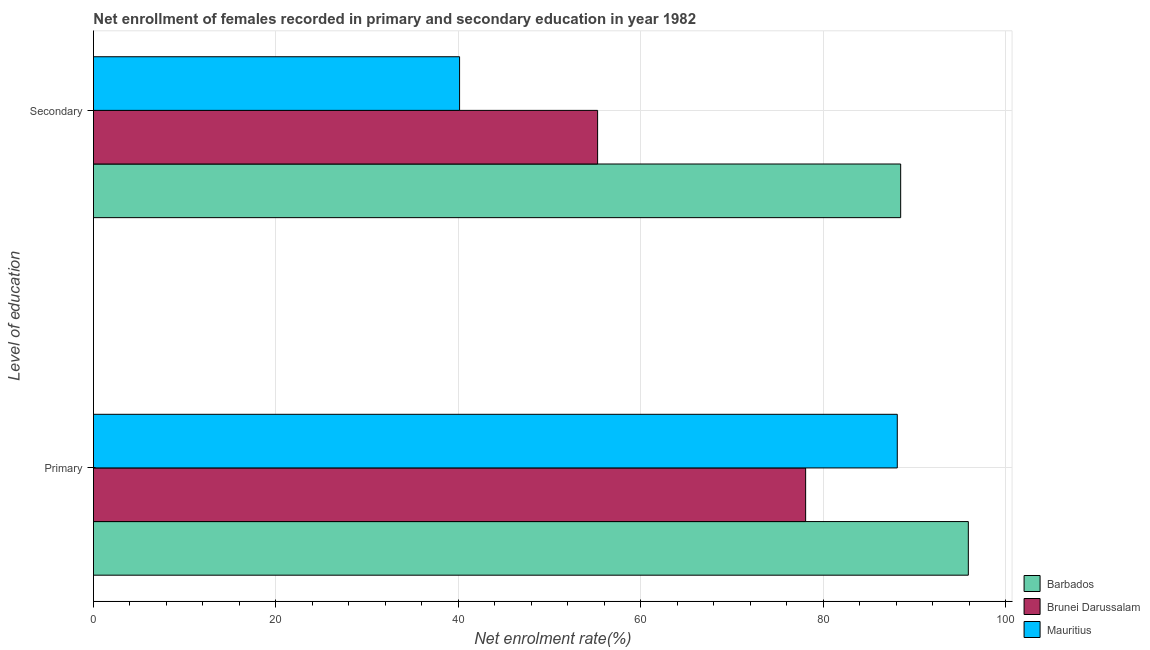How many different coloured bars are there?
Ensure brevity in your answer.  3. How many bars are there on the 1st tick from the top?
Your response must be concise. 3. What is the label of the 1st group of bars from the top?
Offer a terse response. Secondary. What is the enrollment rate in secondary education in Brunei Darussalam?
Your answer should be very brief. 55.26. Across all countries, what is the maximum enrollment rate in secondary education?
Make the answer very short. 88.48. Across all countries, what is the minimum enrollment rate in secondary education?
Provide a short and direct response. 40.13. In which country was the enrollment rate in secondary education maximum?
Your answer should be very brief. Barbados. In which country was the enrollment rate in primary education minimum?
Your answer should be very brief. Brunei Darussalam. What is the total enrollment rate in secondary education in the graph?
Your answer should be very brief. 183.87. What is the difference between the enrollment rate in primary education in Brunei Darussalam and that in Mauritius?
Give a very brief answer. -10.05. What is the difference between the enrollment rate in secondary education in Brunei Darussalam and the enrollment rate in primary education in Mauritius?
Offer a terse response. -32.85. What is the average enrollment rate in primary education per country?
Ensure brevity in your answer.  87.35. What is the difference between the enrollment rate in primary education and enrollment rate in secondary education in Brunei Darussalam?
Your answer should be very brief. 22.8. What is the ratio of the enrollment rate in primary education in Mauritius to that in Brunei Darussalam?
Keep it short and to the point. 1.13. In how many countries, is the enrollment rate in secondary education greater than the average enrollment rate in secondary education taken over all countries?
Your response must be concise. 1. What does the 1st bar from the top in Primary represents?
Keep it short and to the point. Mauritius. What does the 2nd bar from the bottom in Secondary represents?
Your answer should be compact. Brunei Darussalam. How many bars are there?
Your response must be concise. 6. Are all the bars in the graph horizontal?
Provide a succinct answer. Yes. What is the difference between two consecutive major ticks on the X-axis?
Offer a terse response. 20. Are the values on the major ticks of X-axis written in scientific E-notation?
Your answer should be compact. No. Does the graph contain any zero values?
Offer a terse response. No. Does the graph contain grids?
Your answer should be compact. Yes. Where does the legend appear in the graph?
Provide a short and direct response. Bottom right. How many legend labels are there?
Your response must be concise. 3. What is the title of the graph?
Your answer should be compact. Net enrollment of females recorded in primary and secondary education in year 1982. What is the label or title of the X-axis?
Offer a very short reply. Net enrolment rate(%). What is the label or title of the Y-axis?
Give a very brief answer. Level of education. What is the Net enrolment rate(%) in Barbados in Primary?
Your response must be concise. 95.89. What is the Net enrolment rate(%) in Brunei Darussalam in Primary?
Your response must be concise. 78.06. What is the Net enrolment rate(%) in Mauritius in Primary?
Offer a very short reply. 88.11. What is the Net enrolment rate(%) in Barbados in Secondary?
Your response must be concise. 88.48. What is the Net enrolment rate(%) of Brunei Darussalam in Secondary?
Offer a very short reply. 55.26. What is the Net enrolment rate(%) in Mauritius in Secondary?
Offer a very short reply. 40.13. Across all Level of education, what is the maximum Net enrolment rate(%) in Barbados?
Offer a very short reply. 95.89. Across all Level of education, what is the maximum Net enrolment rate(%) of Brunei Darussalam?
Give a very brief answer. 78.06. Across all Level of education, what is the maximum Net enrolment rate(%) of Mauritius?
Your answer should be compact. 88.11. Across all Level of education, what is the minimum Net enrolment rate(%) of Barbados?
Offer a very short reply. 88.48. Across all Level of education, what is the minimum Net enrolment rate(%) of Brunei Darussalam?
Give a very brief answer. 55.26. Across all Level of education, what is the minimum Net enrolment rate(%) in Mauritius?
Make the answer very short. 40.13. What is the total Net enrolment rate(%) of Barbados in the graph?
Your answer should be compact. 184.37. What is the total Net enrolment rate(%) in Brunei Darussalam in the graph?
Make the answer very short. 133.32. What is the total Net enrolment rate(%) of Mauritius in the graph?
Make the answer very short. 128.24. What is the difference between the Net enrolment rate(%) in Barbados in Primary and that in Secondary?
Ensure brevity in your answer.  7.42. What is the difference between the Net enrolment rate(%) of Brunei Darussalam in Primary and that in Secondary?
Provide a succinct answer. 22.8. What is the difference between the Net enrolment rate(%) in Mauritius in Primary and that in Secondary?
Offer a very short reply. 47.98. What is the difference between the Net enrolment rate(%) of Barbados in Primary and the Net enrolment rate(%) of Brunei Darussalam in Secondary?
Provide a short and direct response. 40.63. What is the difference between the Net enrolment rate(%) in Barbados in Primary and the Net enrolment rate(%) in Mauritius in Secondary?
Your answer should be very brief. 55.76. What is the difference between the Net enrolment rate(%) of Brunei Darussalam in Primary and the Net enrolment rate(%) of Mauritius in Secondary?
Your answer should be compact. 37.93. What is the average Net enrolment rate(%) in Barbados per Level of education?
Offer a terse response. 92.19. What is the average Net enrolment rate(%) of Brunei Darussalam per Level of education?
Provide a short and direct response. 66.66. What is the average Net enrolment rate(%) of Mauritius per Level of education?
Your answer should be very brief. 64.12. What is the difference between the Net enrolment rate(%) in Barbados and Net enrolment rate(%) in Brunei Darussalam in Primary?
Your response must be concise. 17.83. What is the difference between the Net enrolment rate(%) in Barbados and Net enrolment rate(%) in Mauritius in Primary?
Make the answer very short. 7.79. What is the difference between the Net enrolment rate(%) of Brunei Darussalam and Net enrolment rate(%) of Mauritius in Primary?
Make the answer very short. -10.05. What is the difference between the Net enrolment rate(%) in Barbados and Net enrolment rate(%) in Brunei Darussalam in Secondary?
Your response must be concise. 33.22. What is the difference between the Net enrolment rate(%) of Barbados and Net enrolment rate(%) of Mauritius in Secondary?
Offer a very short reply. 48.35. What is the difference between the Net enrolment rate(%) of Brunei Darussalam and Net enrolment rate(%) of Mauritius in Secondary?
Your answer should be compact. 15.13. What is the ratio of the Net enrolment rate(%) of Barbados in Primary to that in Secondary?
Give a very brief answer. 1.08. What is the ratio of the Net enrolment rate(%) in Brunei Darussalam in Primary to that in Secondary?
Your answer should be very brief. 1.41. What is the ratio of the Net enrolment rate(%) in Mauritius in Primary to that in Secondary?
Offer a terse response. 2.2. What is the difference between the highest and the second highest Net enrolment rate(%) of Barbados?
Make the answer very short. 7.42. What is the difference between the highest and the second highest Net enrolment rate(%) in Brunei Darussalam?
Make the answer very short. 22.8. What is the difference between the highest and the second highest Net enrolment rate(%) in Mauritius?
Provide a short and direct response. 47.98. What is the difference between the highest and the lowest Net enrolment rate(%) of Barbados?
Make the answer very short. 7.42. What is the difference between the highest and the lowest Net enrolment rate(%) in Brunei Darussalam?
Keep it short and to the point. 22.8. What is the difference between the highest and the lowest Net enrolment rate(%) of Mauritius?
Your answer should be very brief. 47.98. 